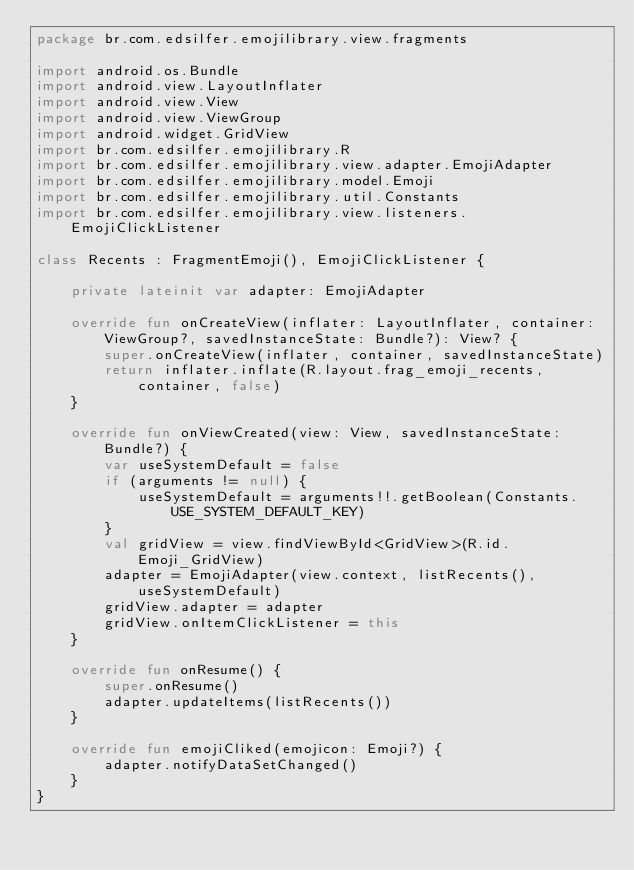<code> <loc_0><loc_0><loc_500><loc_500><_Kotlin_>package br.com.edsilfer.emojilibrary.view.fragments

import android.os.Bundle
import android.view.LayoutInflater
import android.view.View
import android.view.ViewGroup
import android.widget.GridView
import br.com.edsilfer.emojilibrary.R
import br.com.edsilfer.emojilibrary.view.adapter.EmojiAdapter
import br.com.edsilfer.emojilibrary.model.Emoji
import br.com.edsilfer.emojilibrary.util.Constants
import br.com.edsilfer.emojilibrary.view.listeners.EmojiClickListener

class Recents : FragmentEmoji(), EmojiClickListener {

    private lateinit var adapter: EmojiAdapter

    override fun onCreateView(inflater: LayoutInflater, container: ViewGroup?, savedInstanceState: Bundle?): View? {
        super.onCreateView(inflater, container, savedInstanceState)
        return inflater.inflate(R.layout.frag_emoji_recents, container, false)
    }

    override fun onViewCreated(view: View, savedInstanceState: Bundle?) {
        var useSystemDefault = false
        if (arguments != null) {
            useSystemDefault = arguments!!.getBoolean(Constants.USE_SYSTEM_DEFAULT_KEY)
        }
        val gridView = view.findViewById<GridView>(R.id.Emoji_GridView)
        adapter = EmojiAdapter(view.context, listRecents(), useSystemDefault)
        gridView.adapter = adapter
        gridView.onItemClickListener = this
    }

    override fun onResume() {
        super.onResume()
        adapter.updateItems(listRecents())
    }

    override fun emojiCliked(emojicon: Emoji?) {
        adapter.notifyDataSetChanged()
    }
}
</code> 